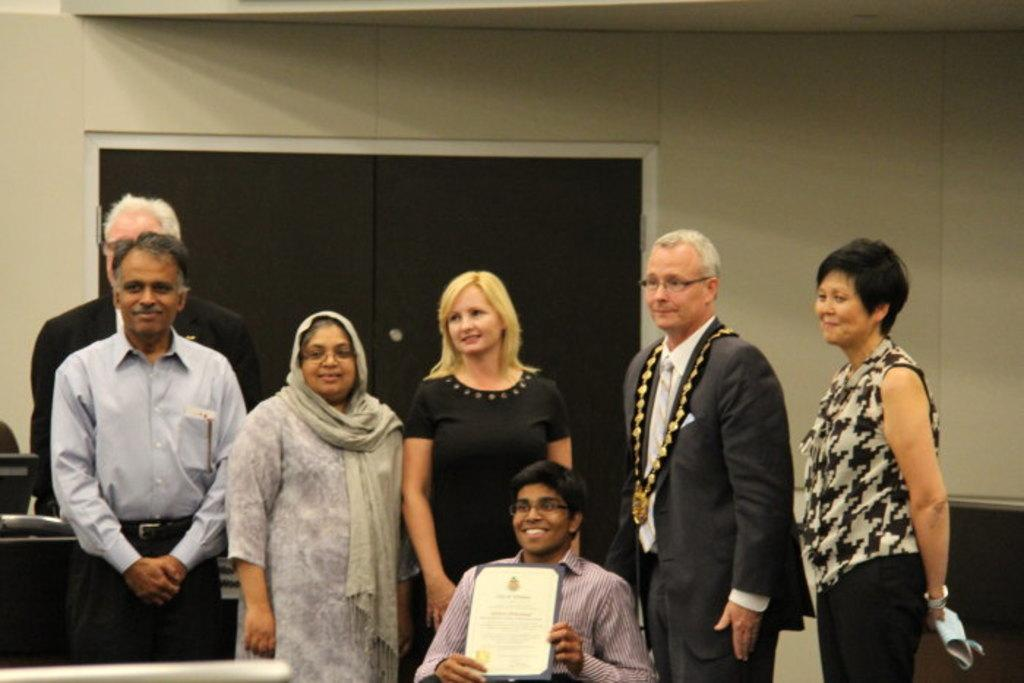How many people are standing in the image? There are many persons standing on the floor in the image. What is the sitting person doing in the image? The sitting person is holding a book. What can be seen in the background of the image? There is a door and a wall visible in the background of the image. What type of advertisement can be seen on the shelf in the image? There is no shelf or advertisement present in the image. What is the sitting person's opinion on the book they are holding? The image does not provide any information about the sitting person's opinion on the book they are holding. 